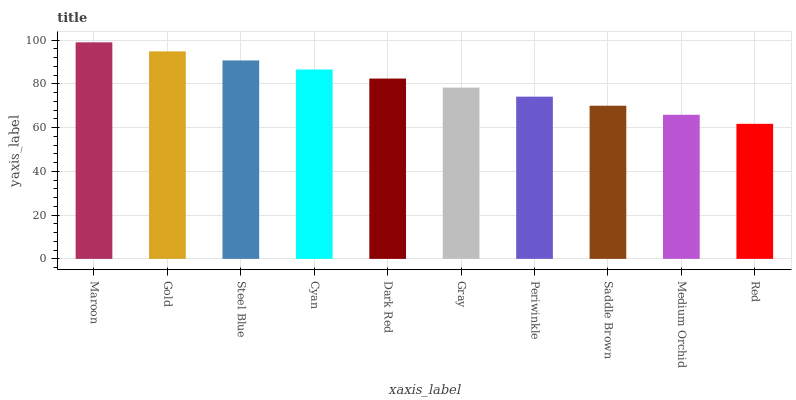Is Gold the minimum?
Answer yes or no. No. Is Gold the maximum?
Answer yes or no. No. Is Maroon greater than Gold?
Answer yes or no. Yes. Is Gold less than Maroon?
Answer yes or no. Yes. Is Gold greater than Maroon?
Answer yes or no. No. Is Maroon less than Gold?
Answer yes or no. No. Is Dark Red the high median?
Answer yes or no. Yes. Is Gray the low median?
Answer yes or no. Yes. Is Periwinkle the high median?
Answer yes or no. No. Is Gold the low median?
Answer yes or no. No. 